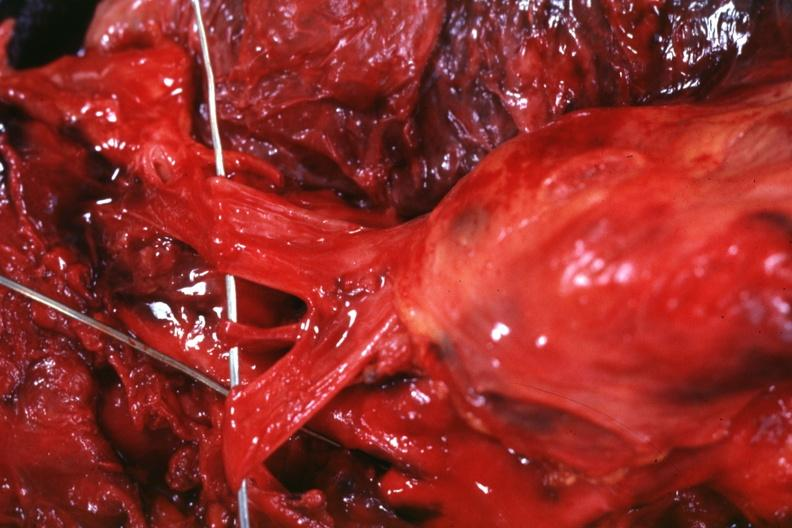s adenosis and ischemia present?
Answer the question using a single word or phrase. No 